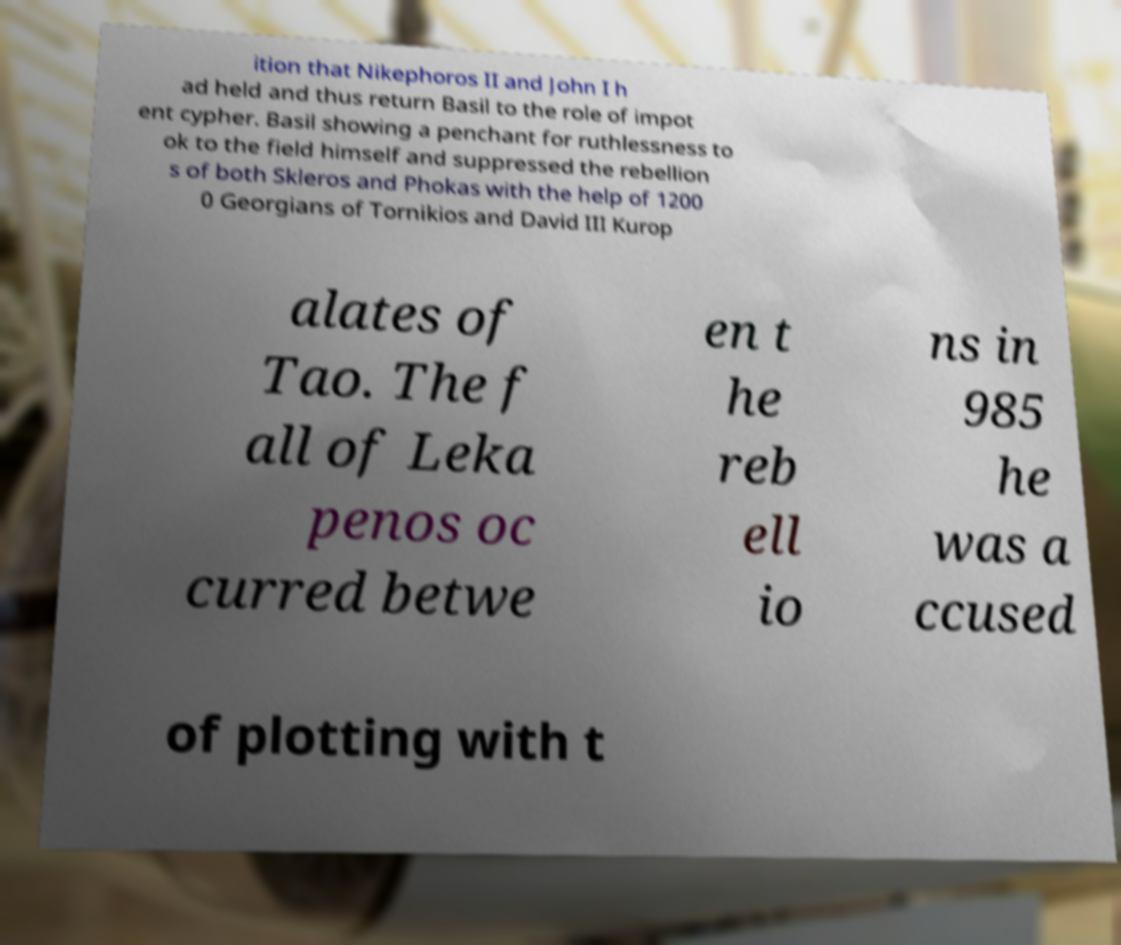Can you read and provide the text displayed in the image?This photo seems to have some interesting text. Can you extract and type it out for me? ition that Nikephoros II and John I h ad held and thus return Basil to the role of impot ent cypher. Basil showing a penchant for ruthlessness to ok to the field himself and suppressed the rebellion s of both Skleros and Phokas with the help of 1200 0 Georgians of Tornikios and David III Kurop alates of Tao. The f all of Leka penos oc curred betwe en t he reb ell io ns in 985 he was a ccused of plotting with t 